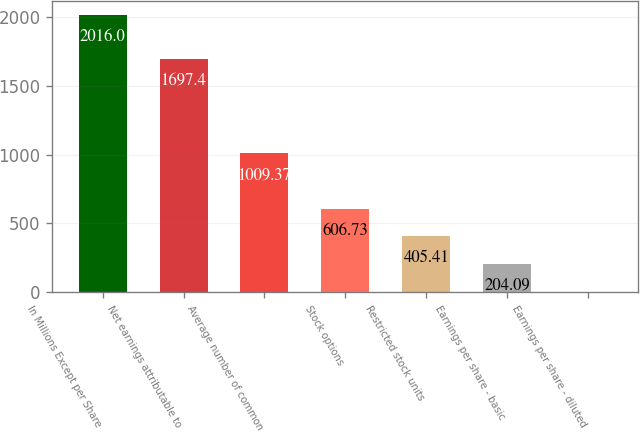<chart> <loc_0><loc_0><loc_500><loc_500><bar_chart><fcel>In Millions Except per Share<fcel>Net earnings attributable to<fcel>Average number of common<fcel>Stock options<fcel>Restricted stock units<fcel>Earnings per share - basic<fcel>Earnings per share - diluted<nl><fcel>2016<fcel>1697.4<fcel>1009.37<fcel>606.73<fcel>405.41<fcel>204.09<fcel>2.77<nl></chart> 